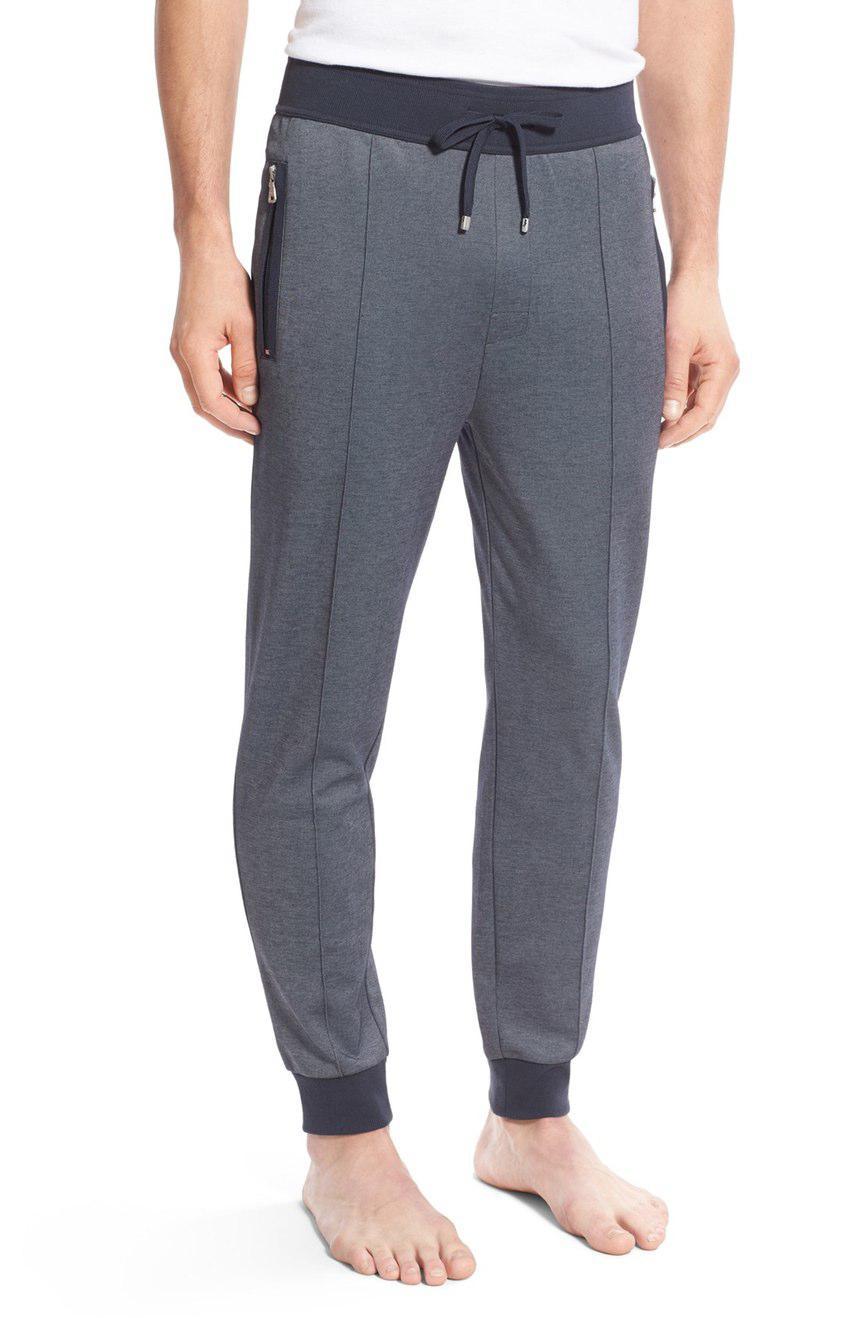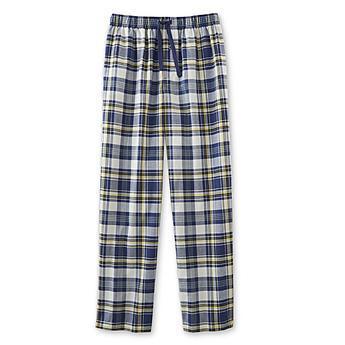The first image is the image on the left, the second image is the image on the right. Considering the images on both sides, is "One pair of pajama pants is a solid color." valid? Answer yes or no. Yes. 